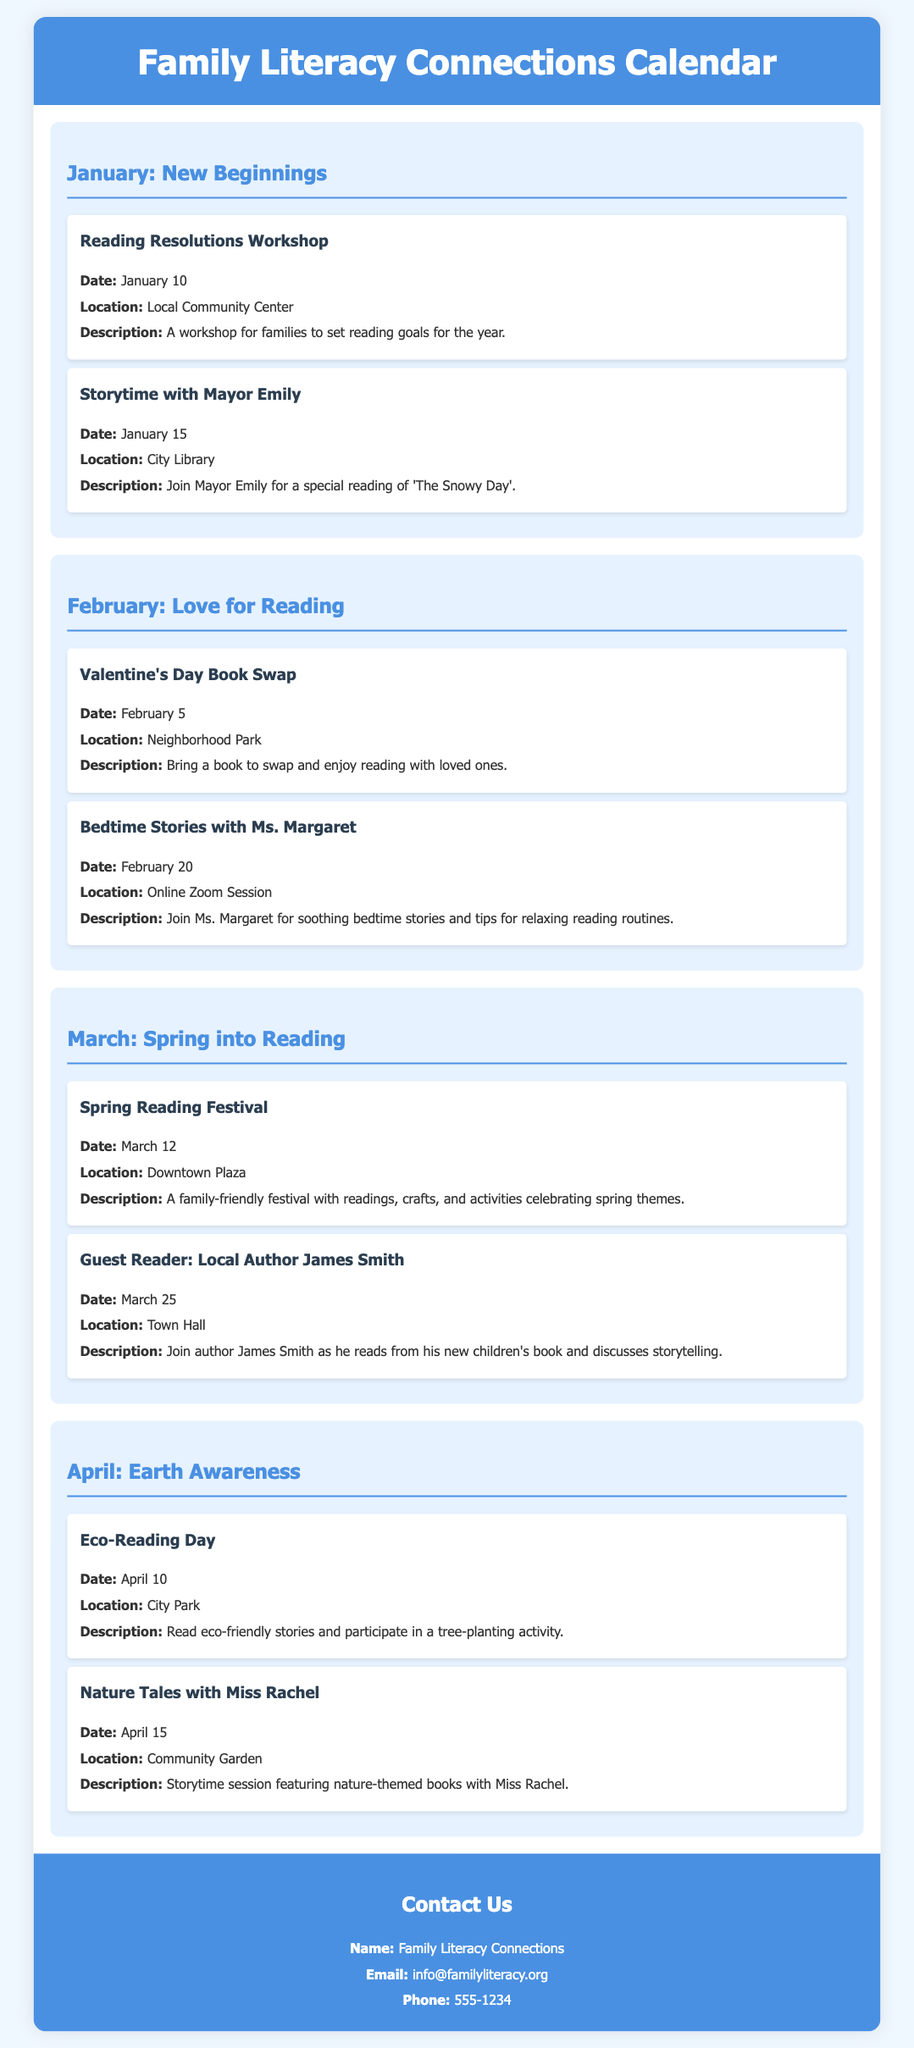What is the title of the document? The title of the document is found in the header section.
Answer: Family Literacy Connections Calendar When is the Reading Resolutions Workshop? The date for the workshop is specified in the January section of the calendar.
Answer: January 10 Who is the guest reader in March? The guest reader is identified in the March section of the event.
Answer: Local Author James Smith What is the location for the Eco-Reading Day event? The location for the event is mentioned in the April section.
Answer: City Park What is the theme for February's events? The theme is introduced in the second month's section of the calendar.
Answer: Love for Reading On what date is the Spring Reading Festival held? The date can be located in the March section of the calendar.
Answer: March 12 How many events are listed for April? The number of events for April can be calculated by counting the entries in that section.
Answer: 2 Who will conduct the Bedtime Stories session? The person leading the session is stated in February's event.
Answer: Ms. Margaret What is the contact email provided in the document? The contact email is found in the contact information section.
Answer: info@familyliteracy.org 